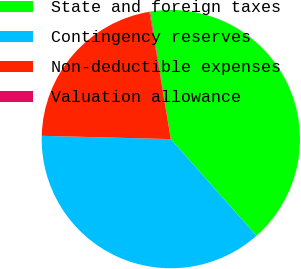<chart> <loc_0><loc_0><loc_500><loc_500><pie_chart><fcel>State and foreign taxes<fcel>Contingency reserves<fcel>Non-deductible expenses<fcel>Valuation allowance<nl><fcel>41.02%<fcel>36.95%<fcel>21.94%<fcel>0.09%<nl></chart> 